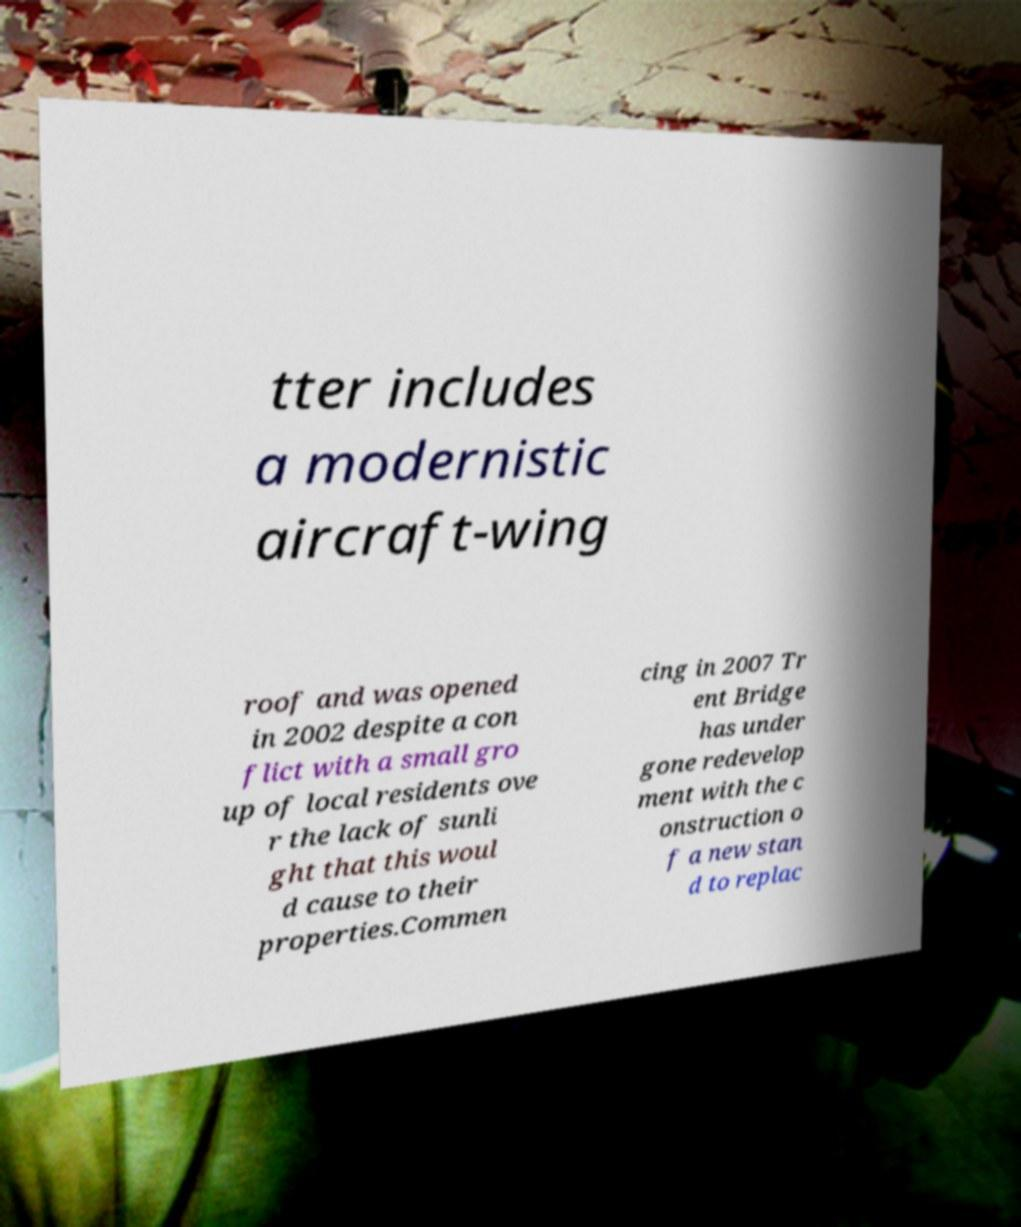Can you read and provide the text displayed in the image?This photo seems to have some interesting text. Can you extract and type it out for me? tter includes a modernistic aircraft-wing roof and was opened in 2002 despite a con flict with a small gro up of local residents ove r the lack of sunli ght that this woul d cause to their properties.Commen cing in 2007 Tr ent Bridge has under gone redevelop ment with the c onstruction o f a new stan d to replac 